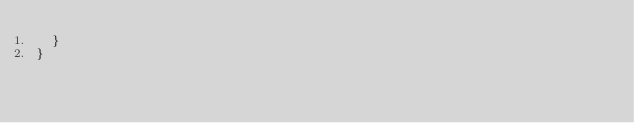<code> <loc_0><loc_0><loc_500><loc_500><_Scala_>  }
}
</code> 